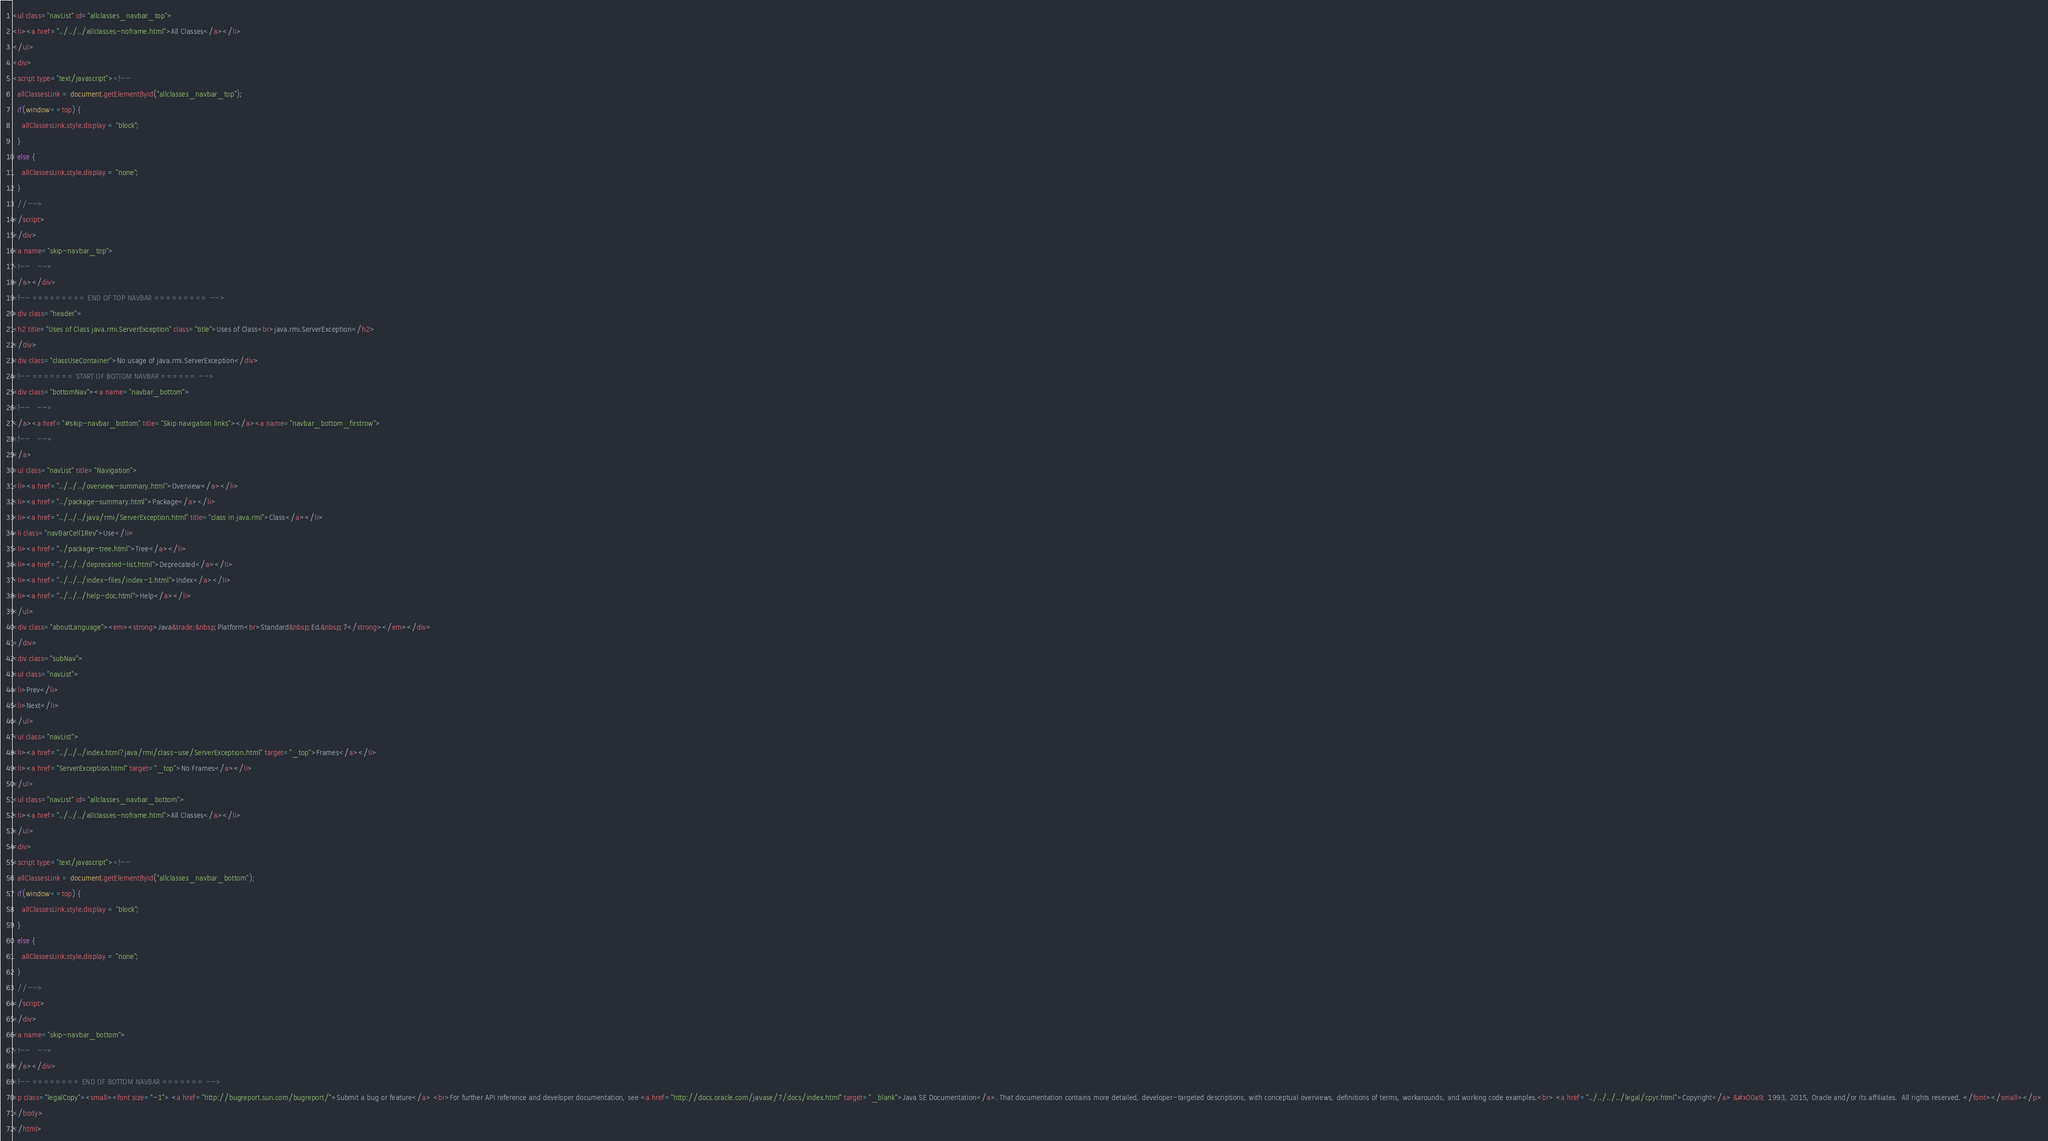Convert code to text. <code><loc_0><loc_0><loc_500><loc_500><_HTML_><ul class="navList" id="allclasses_navbar_top">
<li><a href="../../../allclasses-noframe.html">All Classes</a></li>
</ul>
<div>
<script type="text/javascript"><!--
  allClassesLink = document.getElementById("allclasses_navbar_top");
  if(window==top) {
    allClassesLink.style.display = "block";
  }
  else {
    allClassesLink.style.display = "none";
  }
  //-->
</script>
</div>
<a name="skip-navbar_top">
<!--   -->
</a></div>
<!-- ========= END OF TOP NAVBAR ========= -->
<div class="header">
<h2 title="Uses of Class java.rmi.ServerException" class="title">Uses of Class<br>java.rmi.ServerException</h2>
</div>
<div class="classUseContainer">No usage of java.rmi.ServerException</div>
<!-- ======= START OF BOTTOM NAVBAR ====== -->
<div class="bottomNav"><a name="navbar_bottom">
<!--   -->
</a><a href="#skip-navbar_bottom" title="Skip navigation links"></a><a name="navbar_bottom_firstrow">
<!--   -->
</a>
<ul class="navList" title="Navigation">
<li><a href="../../../overview-summary.html">Overview</a></li>
<li><a href="../package-summary.html">Package</a></li>
<li><a href="../../../java/rmi/ServerException.html" title="class in java.rmi">Class</a></li>
<li class="navBarCell1Rev">Use</li>
<li><a href="../package-tree.html">Tree</a></li>
<li><a href="../../../deprecated-list.html">Deprecated</a></li>
<li><a href="../../../index-files/index-1.html">Index</a></li>
<li><a href="../../../help-doc.html">Help</a></li>
</ul>
<div class="aboutLanguage"><em><strong>Java&trade;&nbsp;Platform<br>Standard&nbsp;Ed.&nbsp;7</strong></em></div>
</div>
<div class="subNav">
<ul class="navList">
<li>Prev</li>
<li>Next</li>
</ul>
<ul class="navList">
<li><a href="../../../index.html?java/rmi/class-use/ServerException.html" target="_top">Frames</a></li>
<li><a href="ServerException.html" target="_top">No Frames</a></li>
</ul>
<ul class="navList" id="allclasses_navbar_bottom">
<li><a href="../../../allclasses-noframe.html">All Classes</a></li>
</ul>
<div>
<script type="text/javascript"><!--
  allClassesLink = document.getElementById("allclasses_navbar_bottom");
  if(window==top) {
    allClassesLink.style.display = "block";
  }
  else {
    allClassesLink.style.display = "none";
  }
  //-->
</script>
</div>
<a name="skip-navbar_bottom">
<!--   -->
</a></div>
<!-- ======== END OF BOTTOM NAVBAR ======= -->
<p class="legalCopy"><small><font size="-1"> <a href="http://bugreport.sun.com/bugreport/">Submit a bug or feature</a> <br>For further API reference and developer documentation, see <a href="http://docs.oracle.com/javase/7/docs/index.html" target="_blank">Java SE Documentation</a>. That documentation contains more detailed, developer-targeted descriptions, with conceptual overviews, definitions of terms, workarounds, and working code examples.<br> <a href="../../../../legal/cpyr.html">Copyright</a> &#x00a9; 1993, 2015, Oracle and/or its affiliates.  All rights reserved. </font></small></p>
</body>
</html>
</code> 